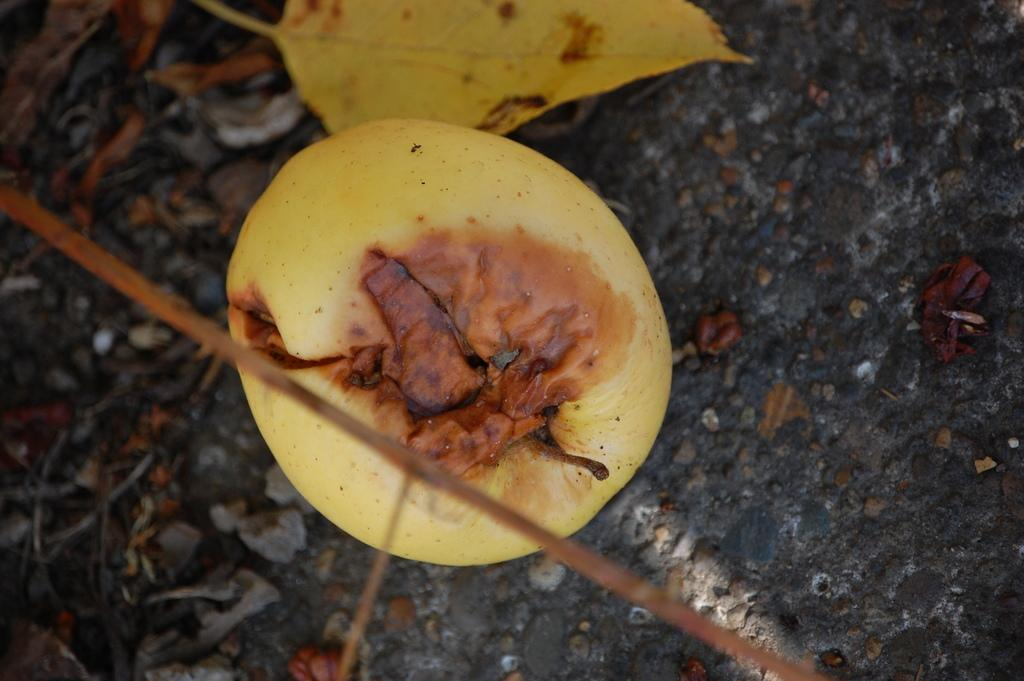What is hanging from the branch in the image? There is a ripened fruit on a branch in the image. What is covering the land below the branch? The land below the branch is covered with dry leaves. What date is marked on the calendar in the image? There is no calendar present in the image. How many cats can be seen in the image? There are no cats present in the image. 